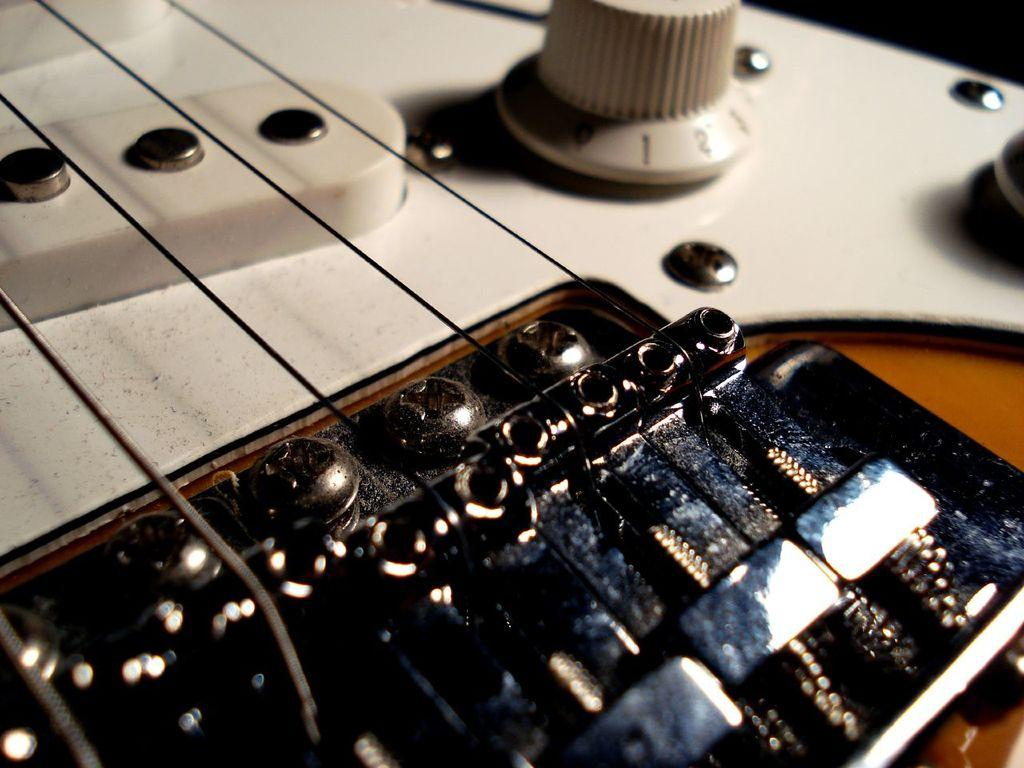What musical instrument is present in the image? There is a guitar in the image. What other object can be seen in the image? There is a regulator in the image. What type of fasteners are visible in the image? There are bolts in the image. How many babies are holding yarn in the image? There are no babies or yarn present in the image. 